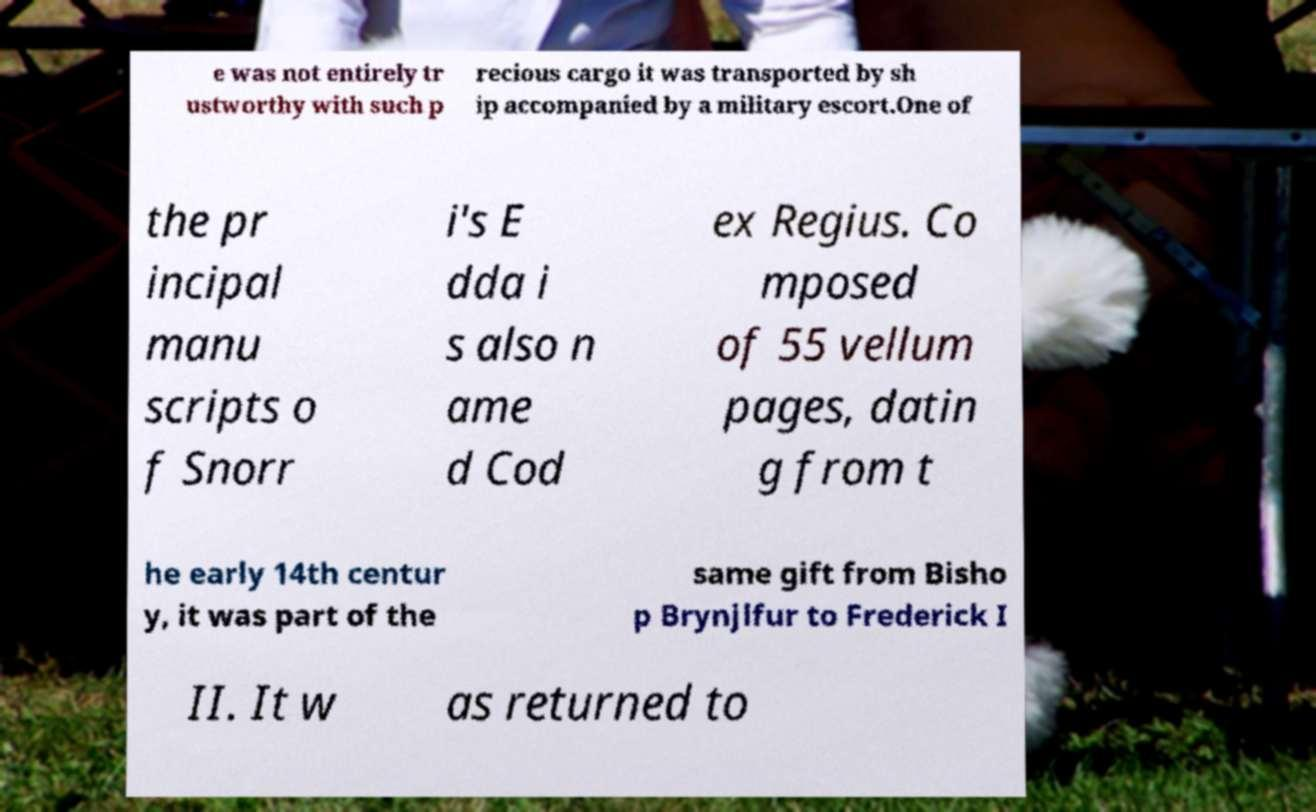Please read and relay the text visible in this image. What does it say? e was not entirely tr ustworthy with such p recious cargo it was transported by sh ip accompanied by a military escort.One of the pr incipal manu scripts o f Snorr i's E dda i s also n ame d Cod ex Regius. Co mposed of 55 vellum pages, datin g from t he early 14th centur y, it was part of the same gift from Bisho p Brynjlfur to Frederick I II. It w as returned to 